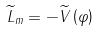Convert formula to latex. <formula><loc_0><loc_0><loc_500><loc_500>\widetilde { L } _ { m } = - \widetilde { V } \left ( \varphi \right )</formula> 